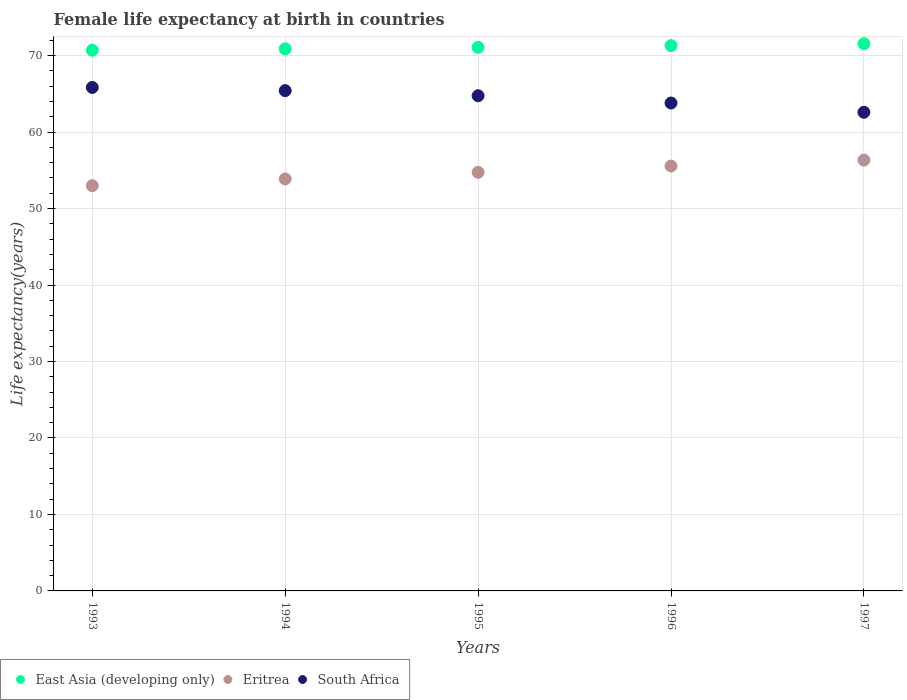What is the female life expectancy at birth in South Africa in 1994?
Keep it short and to the point. 65.42. Across all years, what is the maximum female life expectancy at birth in East Asia (developing only)?
Offer a very short reply. 71.56. Across all years, what is the minimum female life expectancy at birth in South Africa?
Keep it short and to the point. 62.59. In which year was the female life expectancy at birth in South Africa minimum?
Offer a terse response. 1997. What is the total female life expectancy at birth in South Africa in the graph?
Provide a succinct answer. 322.39. What is the difference between the female life expectancy at birth in South Africa in 1993 and that in 1997?
Ensure brevity in your answer.  3.25. What is the difference between the female life expectancy at birth in Eritrea in 1994 and the female life expectancy at birth in East Asia (developing only) in 1995?
Give a very brief answer. -17.21. What is the average female life expectancy at birth in Eritrea per year?
Your answer should be compact. 54.7. In the year 1996, what is the difference between the female life expectancy at birth in South Africa and female life expectancy at birth in East Asia (developing only)?
Your answer should be compact. -7.5. In how many years, is the female life expectancy at birth in East Asia (developing only) greater than 44 years?
Your answer should be very brief. 5. What is the ratio of the female life expectancy at birth in Eritrea in 1995 to that in 1996?
Provide a short and direct response. 0.99. Is the difference between the female life expectancy at birth in South Africa in 1996 and 1997 greater than the difference between the female life expectancy at birth in East Asia (developing only) in 1996 and 1997?
Keep it short and to the point. Yes. What is the difference between the highest and the second highest female life expectancy at birth in Eritrea?
Your answer should be compact. 0.78. What is the difference between the highest and the lowest female life expectancy at birth in Eritrea?
Offer a very short reply. 3.34. In how many years, is the female life expectancy at birth in South Africa greater than the average female life expectancy at birth in South Africa taken over all years?
Your response must be concise. 3. Is the sum of the female life expectancy at birth in Eritrea in 1995 and 1997 greater than the maximum female life expectancy at birth in South Africa across all years?
Your answer should be very brief. Yes. How many dotlines are there?
Offer a terse response. 3. What is the difference between two consecutive major ticks on the Y-axis?
Provide a succinct answer. 10. Does the graph contain any zero values?
Provide a succinct answer. No. Where does the legend appear in the graph?
Make the answer very short. Bottom left. How are the legend labels stacked?
Provide a short and direct response. Horizontal. What is the title of the graph?
Make the answer very short. Female life expectancy at birth in countries. What is the label or title of the X-axis?
Your answer should be compact. Years. What is the label or title of the Y-axis?
Make the answer very short. Life expectancy(years). What is the Life expectancy(years) of East Asia (developing only) in 1993?
Make the answer very short. 70.7. What is the Life expectancy(years) in Eritrea in 1993?
Give a very brief answer. 52.99. What is the Life expectancy(years) of South Africa in 1993?
Your answer should be compact. 65.84. What is the Life expectancy(years) in East Asia (developing only) in 1994?
Provide a succinct answer. 70.89. What is the Life expectancy(years) of Eritrea in 1994?
Make the answer very short. 53.87. What is the Life expectancy(years) of South Africa in 1994?
Your response must be concise. 65.42. What is the Life expectancy(years) of East Asia (developing only) in 1995?
Give a very brief answer. 71.08. What is the Life expectancy(years) in Eritrea in 1995?
Your response must be concise. 54.73. What is the Life expectancy(years) in South Africa in 1995?
Your response must be concise. 64.75. What is the Life expectancy(years) in East Asia (developing only) in 1996?
Make the answer very short. 71.3. What is the Life expectancy(years) of Eritrea in 1996?
Make the answer very short. 55.56. What is the Life expectancy(years) in South Africa in 1996?
Offer a terse response. 63.8. What is the Life expectancy(years) in East Asia (developing only) in 1997?
Provide a short and direct response. 71.56. What is the Life expectancy(years) in Eritrea in 1997?
Your answer should be compact. 56.34. What is the Life expectancy(years) in South Africa in 1997?
Keep it short and to the point. 62.59. Across all years, what is the maximum Life expectancy(years) in East Asia (developing only)?
Your response must be concise. 71.56. Across all years, what is the maximum Life expectancy(years) in Eritrea?
Your answer should be very brief. 56.34. Across all years, what is the maximum Life expectancy(years) of South Africa?
Provide a succinct answer. 65.84. Across all years, what is the minimum Life expectancy(years) of East Asia (developing only)?
Give a very brief answer. 70.7. Across all years, what is the minimum Life expectancy(years) of Eritrea?
Ensure brevity in your answer.  52.99. Across all years, what is the minimum Life expectancy(years) in South Africa?
Provide a short and direct response. 62.59. What is the total Life expectancy(years) of East Asia (developing only) in the graph?
Offer a very short reply. 355.52. What is the total Life expectancy(years) in Eritrea in the graph?
Offer a terse response. 273.49. What is the total Life expectancy(years) in South Africa in the graph?
Make the answer very short. 322.39. What is the difference between the Life expectancy(years) of East Asia (developing only) in 1993 and that in 1994?
Keep it short and to the point. -0.19. What is the difference between the Life expectancy(years) of Eritrea in 1993 and that in 1994?
Your answer should be very brief. -0.88. What is the difference between the Life expectancy(years) of South Africa in 1993 and that in 1994?
Your response must be concise. 0.42. What is the difference between the Life expectancy(years) of East Asia (developing only) in 1993 and that in 1995?
Offer a terse response. -0.38. What is the difference between the Life expectancy(years) of Eritrea in 1993 and that in 1995?
Provide a short and direct response. -1.74. What is the difference between the Life expectancy(years) of South Africa in 1993 and that in 1995?
Your answer should be compact. 1.09. What is the difference between the Life expectancy(years) in East Asia (developing only) in 1993 and that in 1996?
Provide a succinct answer. -0.6. What is the difference between the Life expectancy(years) in Eritrea in 1993 and that in 1996?
Make the answer very short. -2.57. What is the difference between the Life expectancy(years) of South Africa in 1993 and that in 1996?
Offer a terse response. 2.04. What is the difference between the Life expectancy(years) of East Asia (developing only) in 1993 and that in 1997?
Offer a terse response. -0.86. What is the difference between the Life expectancy(years) in Eritrea in 1993 and that in 1997?
Provide a short and direct response. -3.34. What is the difference between the Life expectancy(years) in South Africa in 1993 and that in 1997?
Give a very brief answer. 3.25. What is the difference between the Life expectancy(years) in East Asia (developing only) in 1994 and that in 1995?
Make the answer very short. -0.19. What is the difference between the Life expectancy(years) of Eritrea in 1994 and that in 1995?
Your response must be concise. -0.86. What is the difference between the Life expectancy(years) in South Africa in 1994 and that in 1995?
Provide a short and direct response. 0.67. What is the difference between the Life expectancy(years) of East Asia (developing only) in 1994 and that in 1996?
Give a very brief answer. -0.42. What is the difference between the Life expectancy(years) of Eritrea in 1994 and that in 1996?
Your answer should be compact. -1.69. What is the difference between the Life expectancy(years) of South Africa in 1994 and that in 1996?
Your answer should be very brief. 1.62. What is the difference between the Life expectancy(years) of East Asia (developing only) in 1994 and that in 1997?
Provide a short and direct response. -0.67. What is the difference between the Life expectancy(years) in Eritrea in 1994 and that in 1997?
Give a very brief answer. -2.47. What is the difference between the Life expectancy(years) in South Africa in 1994 and that in 1997?
Provide a short and direct response. 2.83. What is the difference between the Life expectancy(years) in East Asia (developing only) in 1995 and that in 1996?
Provide a succinct answer. -0.22. What is the difference between the Life expectancy(years) of Eritrea in 1995 and that in 1996?
Offer a terse response. -0.83. What is the difference between the Life expectancy(years) in South Africa in 1995 and that in 1996?
Your answer should be compact. 0.95. What is the difference between the Life expectancy(years) of East Asia (developing only) in 1995 and that in 1997?
Offer a terse response. -0.48. What is the difference between the Life expectancy(years) in Eritrea in 1995 and that in 1997?
Offer a terse response. -1.6. What is the difference between the Life expectancy(years) in South Africa in 1995 and that in 1997?
Ensure brevity in your answer.  2.16. What is the difference between the Life expectancy(years) of East Asia (developing only) in 1996 and that in 1997?
Your response must be concise. -0.26. What is the difference between the Life expectancy(years) of Eritrea in 1996 and that in 1997?
Keep it short and to the point. -0.78. What is the difference between the Life expectancy(years) of South Africa in 1996 and that in 1997?
Provide a short and direct response. 1.21. What is the difference between the Life expectancy(years) of East Asia (developing only) in 1993 and the Life expectancy(years) of Eritrea in 1994?
Ensure brevity in your answer.  16.83. What is the difference between the Life expectancy(years) of East Asia (developing only) in 1993 and the Life expectancy(years) of South Africa in 1994?
Your answer should be compact. 5.28. What is the difference between the Life expectancy(years) in Eritrea in 1993 and the Life expectancy(years) in South Africa in 1994?
Your response must be concise. -12.43. What is the difference between the Life expectancy(years) of East Asia (developing only) in 1993 and the Life expectancy(years) of Eritrea in 1995?
Your answer should be very brief. 15.97. What is the difference between the Life expectancy(years) of East Asia (developing only) in 1993 and the Life expectancy(years) of South Africa in 1995?
Your answer should be very brief. 5.95. What is the difference between the Life expectancy(years) of Eritrea in 1993 and the Life expectancy(years) of South Africa in 1995?
Provide a short and direct response. -11.76. What is the difference between the Life expectancy(years) of East Asia (developing only) in 1993 and the Life expectancy(years) of Eritrea in 1996?
Offer a very short reply. 15.14. What is the difference between the Life expectancy(years) of East Asia (developing only) in 1993 and the Life expectancy(years) of South Africa in 1996?
Your answer should be compact. 6.9. What is the difference between the Life expectancy(years) in Eritrea in 1993 and the Life expectancy(years) in South Africa in 1996?
Keep it short and to the point. -10.81. What is the difference between the Life expectancy(years) of East Asia (developing only) in 1993 and the Life expectancy(years) of Eritrea in 1997?
Your response must be concise. 14.36. What is the difference between the Life expectancy(years) of East Asia (developing only) in 1993 and the Life expectancy(years) of South Africa in 1997?
Offer a very short reply. 8.11. What is the difference between the Life expectancy(years) of Eritrea in 1993 and the Life expectancy(years) of South Africa in 1997?
Your answer should be very brief. -9.6. What is the difference between the Life expectancy(years) in East Asia (developing only) in 1994 and the Life expectancy(years) in Eritrea in 1995?
Give a very brief answer. 16.15. What is the difference between the Life expectancy(years) of East Asia (developing only) in 1994 and the Life expectancy(years) of South Africa in 1995?
Offer a terse response. 6.14. What is the difference between the Life expectancy(years) in Eritrea in 1994 and the Life expectancy(years) in South Africa in 1995?
Your answer should be compact. -10.88. What is the difference between the Life expectancy(years) of East Asia (developing only) in 1994 and the Life expectancy(years) of Eritrea in 1996?
Give a very brief answer. 15.33. What is the difference between the Life expectancy(years) in East Asia (developing only) in 1994 and the Life expectancy(years) in South Africa in 1996?
Your answer should be compact. 7.09. What is the difference between the Life expectancy(years) in Eritrea in 1994 and the Life expectancy(years) in South Africa in 1996?
Your answer should be very brief. -9.93. What is the difference between the Life expectancy(years) of East Asia (developing only) in 1994 and the Life expectancy(years) of Eritrea in 1997?
Your response must be concise. 14.55. What is the difference between the Life expectancy(years) in East Asia (developing only) in 1994 and the Life expectancy(years) in South Africa in 1997?
Give a very brief answer. 8.3. What is the difference between the Life expectancy(years) of Eritrea in 1994 and the Life expectancy(years) of South Africa in 1997?
Offer a terse response. -8.72. What is the difference between the Life expectancy(years) in East Asia (developing only) in 1995 and the Life expectancy(years) in Eritrea in 1996?
Ensure brevity in your answer.  15.52. What is the difference between the Life expectancy(years) in East Asia (developing only) in 1995 and the Life expectancy(years) in South Africa in 1996?
Ensure brevity in your answer.  7.28. What is the difference between the Life expectancy(years) of Eritrea in 1995 and the Life expectancy(years) of South Africa in 1996?
Your response must be concise. -9.07. What is the difference between the Life expectancy(years) of East Asia (developing only) in 1995 and the Life expectancy(years) of Eritrea in 1997?
Your answer should be compact. 14.74. What is the difference between the Life expectancy(years) in East Asia (developing only) in 1995 and the Life expectancy(years) in South Africa in 1997?
Provide a short and direct response. 8.49. What is the difference between the Life expectancy(years) of Eritrea in 1995 and the Life expectancy(years) of South Africa in 1997?
Your answer should be very brief. -7.86. What is the difference between the Life expectancy(years) of East Asia (developing only) in 1996 and the Life expectancy(years) of Eritrea in 1997?
Keep it short and to the point. 14.96. What is the difference between the Life expectancy(years) of East Asia (developing only) in 1996 and the Life expectancy(years) of South Africa in 1997?
Provide a short and direct response. 8.71. What is the difference between the Life expectancy(years) of Eritrea in 1996 and the Life expectancy(years) of South Africa in 1997?
Keep it short and to the point. -7.03. What is the average Life expectancy(years) in East Asia (developing only) per year?
Your response must be concise. 71.1. What is the average Life expectancy(years) in Eritrea per year?
Make the answer very short. 54.7. What is the average Life expectancy(years) of South Africa per year?
Your answer should be compact. 64.48. In the year 1993, what is the difference between the Life expectancy(years) of East Asia (developing only) and Life expectancy(years) of Eritrea?
Your answer should be compact. 17.71. In the year 1993, what is the difference between the Life expectancy(years) in East Asia (developing only) and Life expectancy(years) in South Africa?
Give a very brief answer. 4.86. In the year 1993, what is the difference between the Life expectancy(years) of Eritrea and Life expectancy(years) of South Africa?
Offer a very short reply. -12.85. In the year 1994, what is the difference between the Life expectancy(years) of East Asia (developing only) and Life expectancy(years) of Eritrea?
Ensure brevity in your answer.  17.02. In the year 1994, what is the difference between the Life expectancy(years) in East Asia (developing only) and Life expectancy(years) in South Africa?
Offer a terse response. 5.47. In the year 1994, what is the difference between the Life expectancy(years) in Eritrea and Life expectancy(years) in South Africa?
Offer a terse response. -11.55. In the year 1995, what is the difference between the Life expectancy(years) of East Asia (developing only) and Life expectancy(years) of Eritrea?
Give a very brief answer. 16.35. In the year 1995, what is the difference between the Life expectancy(years) of East Asia (developing only) and Life expectancy(years) of South Africa?
Offer a terse response. 6.33. In the year 1995, what is the difference between the Life expectancy(years) in Eritrea and Life expectancy(years) in South Africa?
Ensure brevity in your answer.  -10.02. In the year 1996, what is the difference between the Life expectancy(years) in East Asia (developing only) and Life expectancy(years) in Eritrea?
Provide a short and direct response. 15.74. In the year 1996, what is the difference between the Life expectancy(years) in East Asia (developing only) and Life expectancy(years) in South Africa?
Your answer should be compact. 7.5. In the year 1996, what is the difference between the Life expectancy(years) in Eritrea and Life expectancy(years) in South Africa?
Provide a succinct answer. -8.24. In the year 1997, what is the difference between the Life expectancy(years) in East Asia (developing only) and Life expectancy(years) in Eritrea?
Make the answer very short. 15.22. In the year 1997, what is the difference between the Life expectancy(years) of East Asia (developing only) and Life expectancy(years) of South Africa?
Offer a very short reply. 8.97. In the year 1997, what is the difference between the Life expectancy(years) of Eritrea and Life expectancy(years) of South Africa?
Ensure brevity in your answer.  -6.25. What is the ratio of the Life expectancy(years) in East Asia (developing only) in 1993 to that in 1994?
Your response must be concise. 1. What is the ratio of the Life expectancy(years) of Eritrea in 1993 to that in 1994?
Ensure brevity in your answer.  0.98. What is the ratio of the Life expectancy(years) of South Africa in 1993 to that in 1994?
Provide a succinct answer. 1.01. What is the ratio of the Life expectancy(years) in East Asia (developing only) in 1993 to that in 1995?
Your response must be concise. 0.99. What is the ratio of the Life expectancy(years) in Eritrea in 1993 to that in 1995?
Your response must be concise. 0.97. What is the ratio of the Life expectancy(years) of South Africa in 1993 to that in 1995?
Provide a succinct answer. 1.02. What is the ratio of the Life expectancy(years) in East Asia (developing only) in 1993 to that in 1996?
Your answer should be compact. 0.99. What is the ratio of the Life expectancy(years) of Eritrea in 1993 to that in 1996?
Provide a succinct answer. 0.95. What is the ratio of the Life expectancy(years) of South Africa in 1993 to that in 1996?
Ensure brevity in your answer.  1.03. What is the ratio of the Life expectancy(years) of Eritrea in 1993 to that in 1997?
Your answer should be compact. 0.94. What is the ratio of the Life expectancy(years) of South Africa in 1993 to that in 1997?
Provide a succinct answer. 1.05. What is the ratio of the Life expectancy(years) of Eritrea in 1994 to that in 1995?
Provide a short and direct response. 0.98. What is the ratio of the Life expectancy(years) in South Africa in 1994 to that in 1995?
Give a very brief answer. 1.01. What is the ratio of the Life expectancy(years) in East Asia (developing only) in 1994 to that in 1996?
Keep it short and to the point. 0.99. What is the ratio of the Life expectancy(years) of Eritrea in 1994 to that in 1996?
Offer a terse response. 0.97. What is the ratio of the Life expectancy(years) in South Africa in 1994 to that in 1996?
Offer a terse response. 1.03. What is the ratio of the Life expectancy(years) of East Asia (developing only) in 1994 to that in 1997?
Keep it short and to the point. 0.99. What is the ratio of the Life expectancy(years) in Eritrea in 1994 to that in 1997?
Offer a terse response. 0.96. What is the ratio of the Life expectancy(years) of South Africa in 1994 to that in 1997?
Ensure brevity in your answer.  1.05. What is the ratio of the Life expectancy(years) of Eritrea in 1995 to that in 1996?
Offer a terse response. 0.99. What is the ratio of the Life expectancy(years) of South Africa in 1995 to that in 1996?
Give a very brief answer. 1.01. What is the ratio of the Life expectancy(years) in East Asia (developing only) in 1995 to that in 1997?
Provide a succinct answer. 0.99. What is the ratio of the Life expectancy(years) in Eritrea in 1995 to that in 1997?
Provide a succinct answer. 0.97. What is the ratio of the Life expectancy(years) in South Africa in 1995 to that in 1997?
Ensure brevity in your answer.  1.03. What is the ratio of the Life expectancy(years) of Eritrea in 1996 to that in 1997?
Your response must be concise. 0.99. What is the ratio of the Life expectancy(years) in South Africa in 1996 to that in 1997?
Provide a short and direct response. 1.02. What is the difference between the highest and the second highest Life expectancy(years) in East Asia (developing only)?
Provide a succinct answer. 0.26. What is the difference between the highest and the second highest Life expectancy(years) in Eritrea?
Your answer should be compact. 0.78. What is the difference between the highest and the second highest Life expectancy(years) in South Africa?
Keep it short and to the point. 0.42. What is the difference between the highest and the lowest Life expectancy(years) of East Asia (developing only)?
Your answer should be compact. 0.86. What is the difference between the highest and the lowest Life expectancy(years) of Eritrea?
Ensure brevity in your answer.  3.34. What is the difference between the highest and the lowest Life expectancy(years) in South Africa?
Your answer should be very brief. 3.25. 